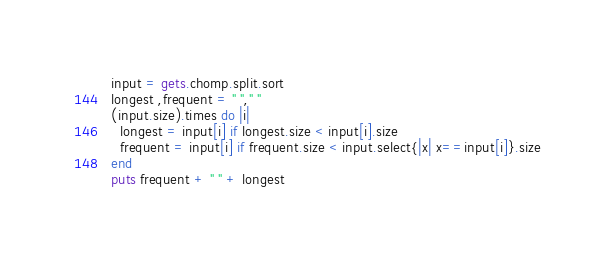Convert code to text. <code><loc_0><loc_0><loc_500><loc_500><_Ruby_>input = gets.chomp.split.sort
longest ,frequent = " "," "
(input.size).times do |i|
  longest = input[i] if longest.size < input[i].size
  frequent = input[i] if frequent.size < input.select{|x| x==input[i]}.size
end
puts frequent + " " + longest</code> 